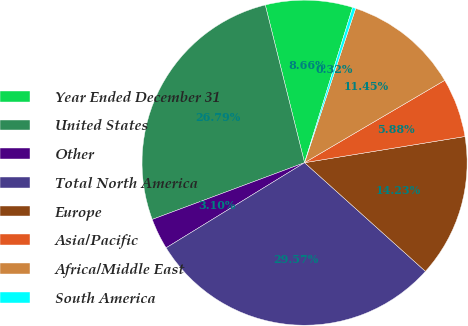Convert chart to OTSL. <chart><loc_0><loc_0><loc_500><loc_500><pie_chart><fcel>Year Ended December 31<fcel>United States<fcel>Other<fcel>Total North America<fcel>Europe<fcel>Asia/Pacific<fcel>Africa/Middle East<fcel>South America<nl><fcel>8.66%<fcel>26.79%<fcel>3.1%<fcel>29.57%<fcel>14.23%<fcel>5.88%<fcel>11.45%<fcel>0.32%<nl></chart> 